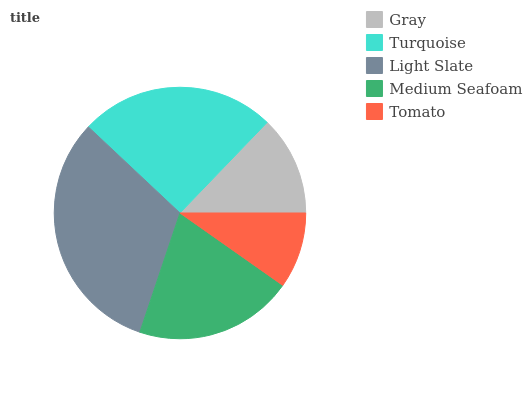Is Tomato the minimum?
Answer yes or no. Yes. Is Light Slate the maximum?
Answer yes or no. Yes. Is Turquoise the minimum?
Answer yes or no. No. Is Turquoise the maximum?
Answer yes or no. No. Is Turquoise greater than Gray?
Answer yes or no. Yes. Is Gray less than Turquoise?
Answer yes or no. Yes. Is Gray greater than Turquoise?
Answer yes or no. No. Is Turquoise less than Gray?
Answer yes or no. No. Is Medium Seafoam the high median?
Answer yes or no. Yes. Is Medium Seafoam the low median?
Answer yes or no. Yes. Is Tomato the high median?
Answer yes or no. No. Is Tomato the low median?
Answer yes or no. No. 